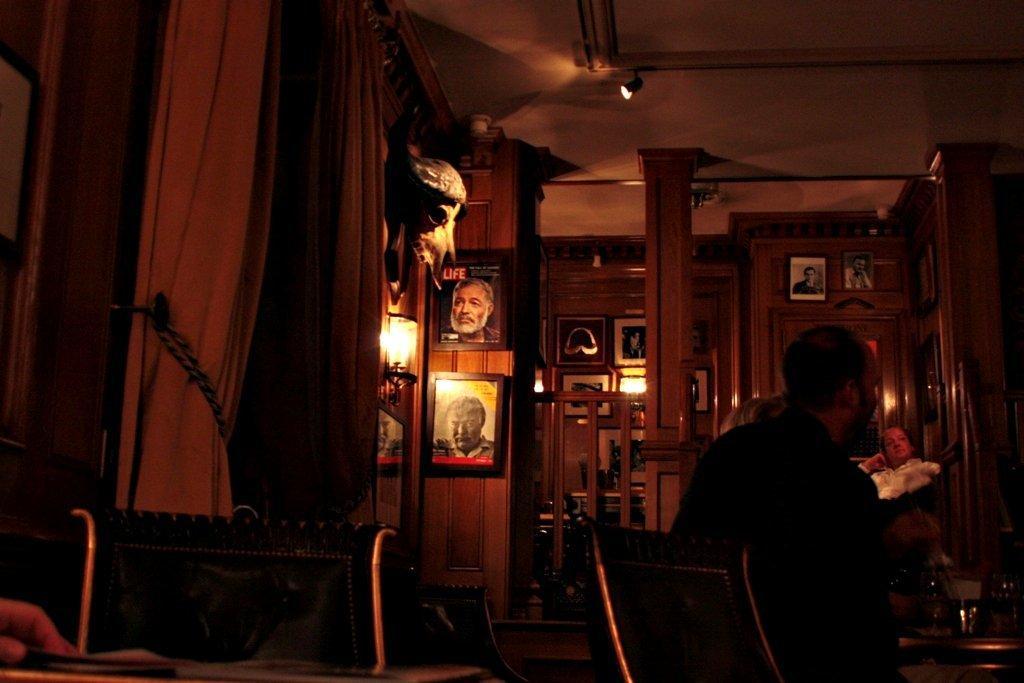How would you summarize this image in a sentence or two? In this picture I can see photo frames on the wall. I can see light arrangements on the roof. I can see sitting chairs. I can see people. 